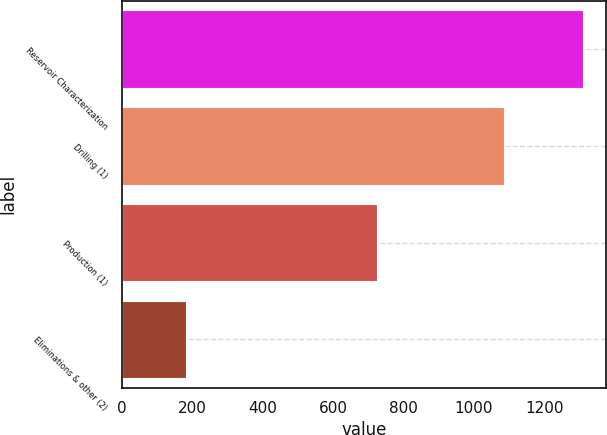Convert chart to OTSL. <chart><loc_0><loc_0><loc_500><loc_500><bar_chart><fcel>Reservoir Characterization<fcel>Drilling (1)<fcel>Production (1)<fcel>Eliminations & other (2)<nl><fcel>1311<fcel>1086<fcel>724<fcel>181<nl></chart> 